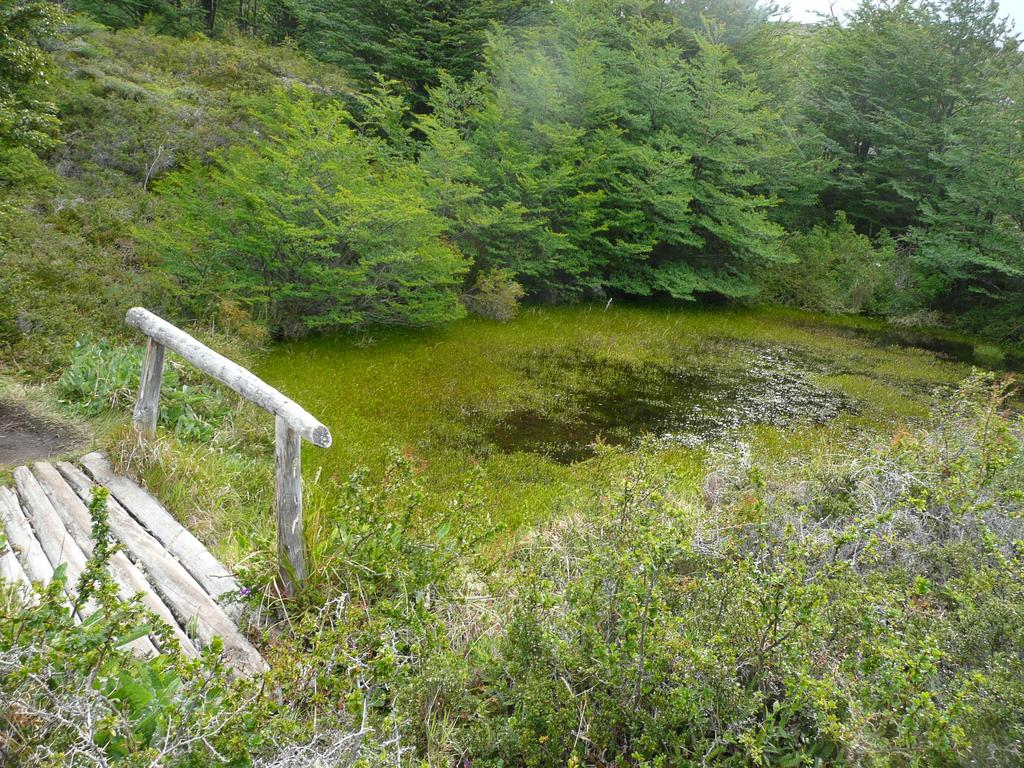What objects can be seen on the right side of the image? There are wooden sticks on the right side of the image. What type of structure is present in the image? There is a bridge in the image. What type of vegetation is visible in the image? There are plants, trees, and grass in the image. What natural element is present in the image? There is water in the image. What part of the natural environment is visible in the image? The sky is visible in the image. Can you tell me how many hooks are hanging from the bridge in the image? There are no hooks visible on the bridge in the image. How does the grass move in the image? The grass does not move in the image; it is stationary. 